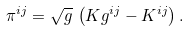Convert formula to latex. <formula><loc_0><loc_0><loc_500><loc_500>\pi ^ { i j } = \sqrt { g } \, \left ( K g ^ { i j } - K ^ { i j } \right ) .</formula> 